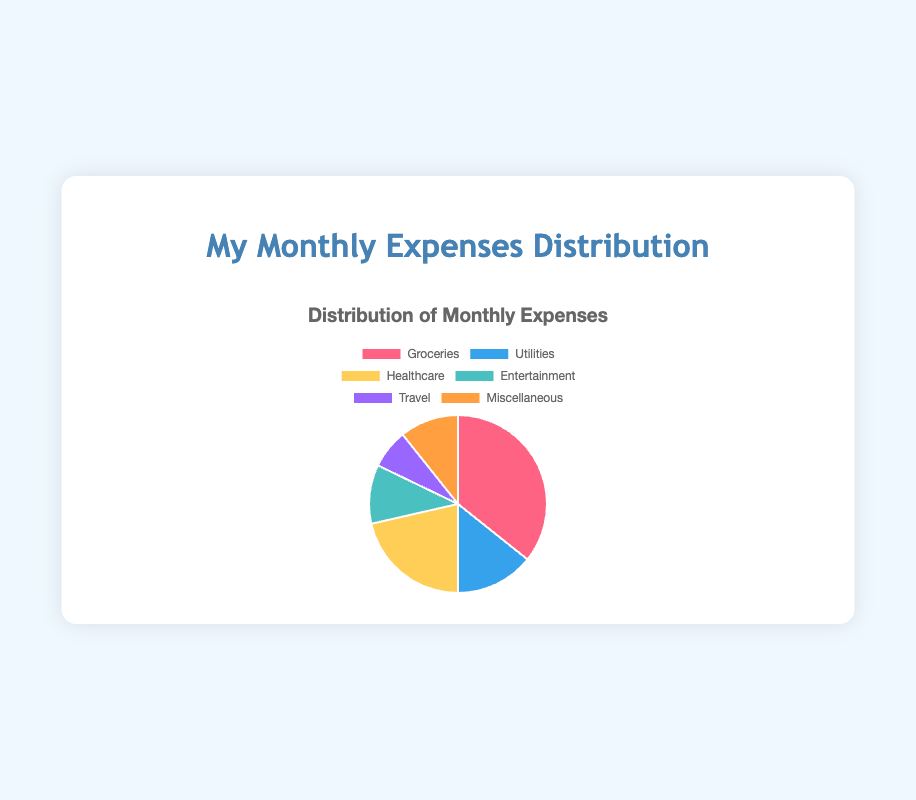Which expense category has the highest expenditure? The Groceries category shows the largest slice in the pie chart with an amount of $500.
Answer: Groceries What is the total amount spent on Entertainment and Travel together? To find the total amount spent on Entertainment and Travel, add the amounts for those categories: $150 (Entertainment) + $100 (Travel) = $250.
Answer: $250 What is the difference between the spending on Groceries and Utilities? To find the difference between Groceries and Utilities, subtract the amount spent on Utilities from the amount spent on Groceries: $500 (Groceries) - $200 (Utilities) = $300.
Answer: $300 Which category has the smallest expenditure? The Travel category has the smallest slice in the pie chart with an amount of $100.
Answer: Travel What percentage of the total monthly expenses is spent on Healthcare? First, calculate the total monthly expenses: $500 (Groceries) + $200 (Utilities) + $300 (Healthcare) + $150 (Entertainment) + $100 (Travel) + $150 (Miscellaneous) = $1400. Then, calculate the percentage for Healthcare: ($300 / $1400) * 100% = approximately 21.43%.
Answer: approximately 21.43% By how much does the amount spent on Groceries exceed the amount spent on Healthcare? Subtract the amount spent on Healthcare from the amount spent on Groceries: $500 (Groceries) - $300 (Healthcare) = $200.
Answer: $200 How much more is spent on Groceries than on the categories of Entertainment and Miscellaneous combined? First, calculate the combined total of Entertainment and Miscellaneous: $150 (Entertainment) + $150 (Miscellaneous) = $300. Then, subtract this combined amount from the amount spent on Groceries: $500 (Groceries) - $300 (Entertainment and Miscellaneous) = $200.
Answer: $200 What is the combined total expenditure on categories other than Groceries? Sum the amounts for all categories except Groceries: $200 (Utilities) + $300 (Healthcare) + $150 (Entertainment) + $100 (Travel) + $150 (Miscellaneous) = $900.
Answer: $900 What fraction of the total expenses is spent on Utilities? First, calculate the total monthly expenses: $500 (Groceries) + $200 (Utilities) + $300 (Healthcare) + $150 (Entertainment) + $100 (Travel) + $150 (Miscellaneous) = $1400. Then, express the amount for Utilities as a fraction of the total: $200 / $1400 = 1/7.
Answer: 1/7 If the total expenditure next month increases by 10%, how much would be spent on Utilities if the spending on Utilities remains the same percentage of the total? First, calculate the current percentage for Utilities: ($200 / $1400) * 100% = approximately 14.29%. Calculate the increased total expenditure for next month: $1400 * 1.10 = $1540. Then, calculate the spending on Utilities next month: 14.29% of $1540 = approximately $220.14.
Answer: approximately $220.14 